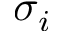<formula> <loc_0><loc_0><loc_500><loc_500>\sigma _ { i }</formula> 